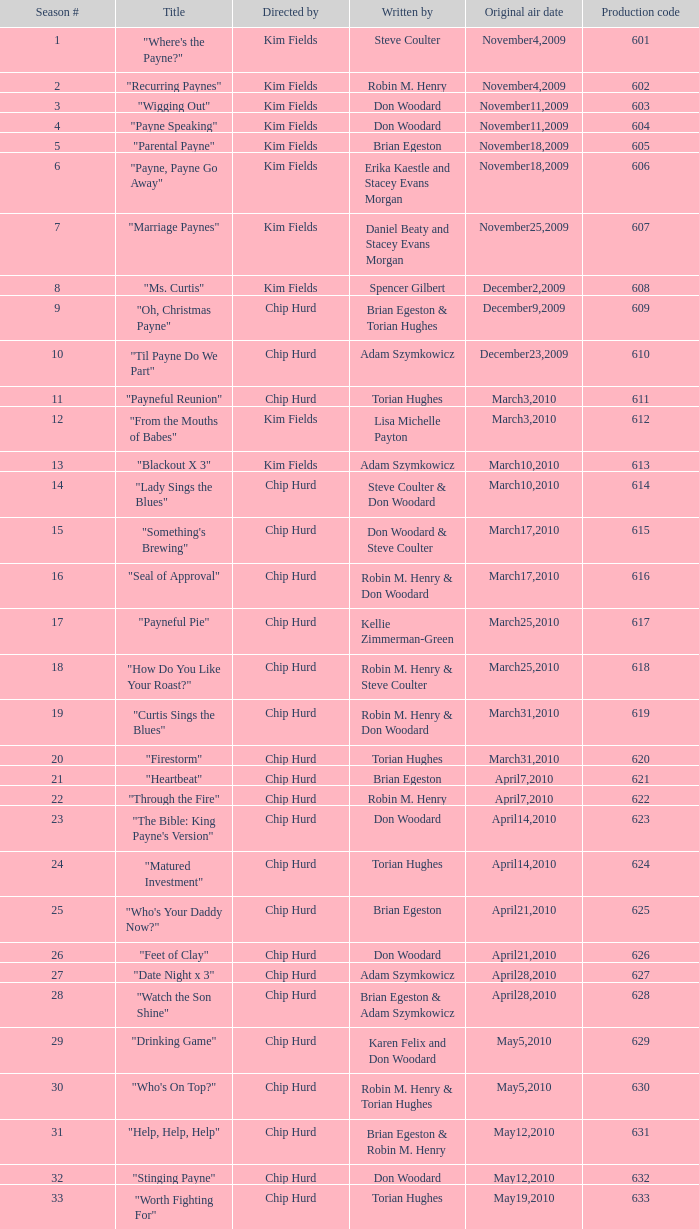Can you provide the title of the episode associated with the production code 624? "Matured Investment". 